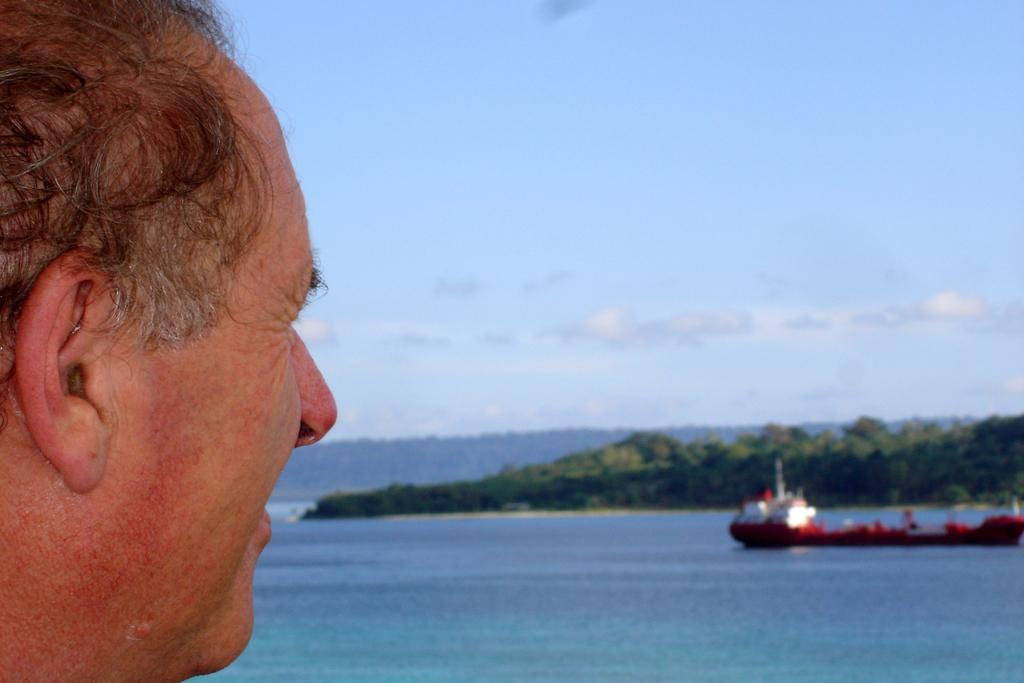What is the main subject of the image? There is a person's face in the image. What can be seen in the water in the image? There is a boat on the water surface in the image. What type of landscape is visible in the background of the image? There are hills visible in the background of the image. Can you tell me how many ants are crawling on the person's face in the image? There are no ants present on the person's face in the image. What type of building can be seen in the background of the image? There is no building visible in the background of the image; only hills are present. 